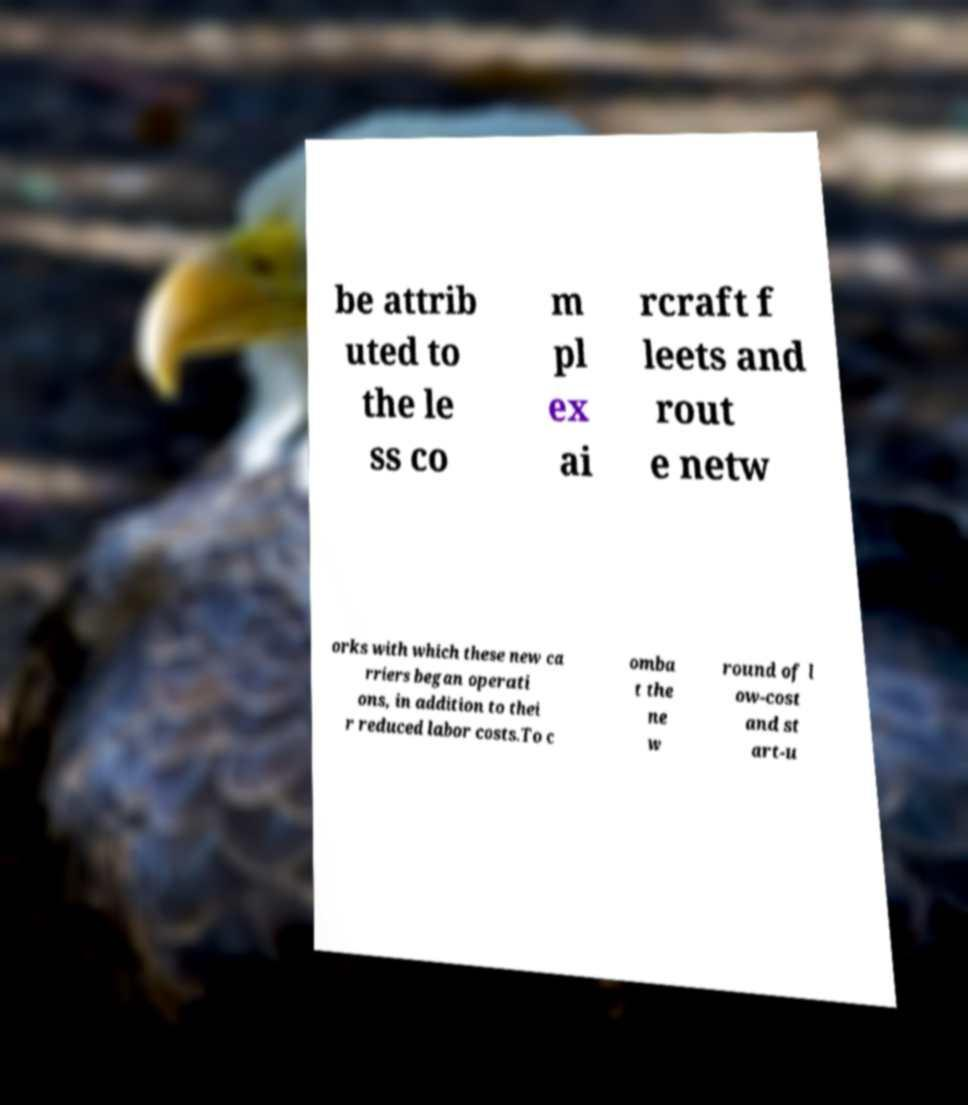For documentation purposes, I need the text within this image transcribed. Could you provide that? be attrib uted to the le ss co m pl ex ai rcraft f leets and rout e netw orks with which these new ca rriers began operati ons, in addition to thei r reduced labor costs.To c omba t the ne w round of l ow-cost and st art-u 